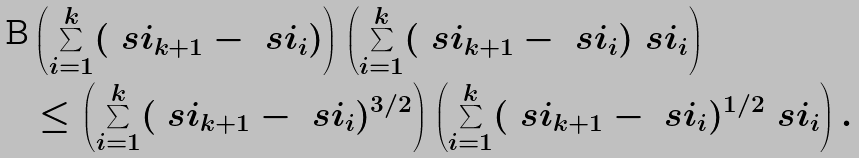Convert formula to latex. <formula><loc_0><loc_0><loc_500><loc_500>& \left ( \sum _ { i = 1 } ^ { k } ( \ s i _ { k + 1 } - \ s i _ { i } ) \right ) \left ( \sum _ { i = 1 } ^ { k } ( \ s i _ { k + 1 } - \ s i _ { i } ) \ s i _ { i } \right ) \\ & \leq \left ( \sum _ { i = 1 } ^ { k } ( \ s i _ { k + 1 } - \ s i _ { i } ) ^ { 3 / 2 } \right ) \left ( \sum _ { i = 1 } ^ { k } ( \ s i _ { k + 1 } - \ s i _ { i } ) ^ { 1 / 2 } \ s i _ { i } \right ) .</formula> 